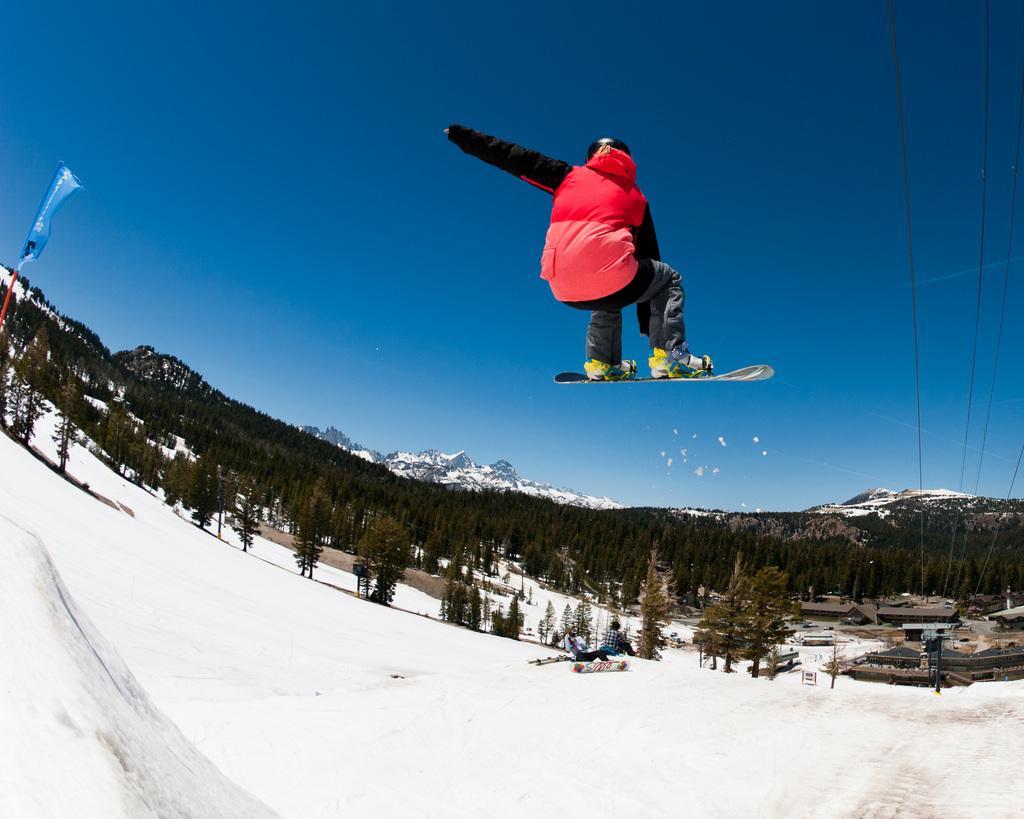Can you describe this image briefly? In this image I can see ground and on it I can see snow. In the center of this image I can see a person is standing on a snow skating board and I can see these two are in the air. On the right side of this image I can see few wires and on the left side I can see blue colour thing. In the background I can see number of trees, mountains and the sky. 